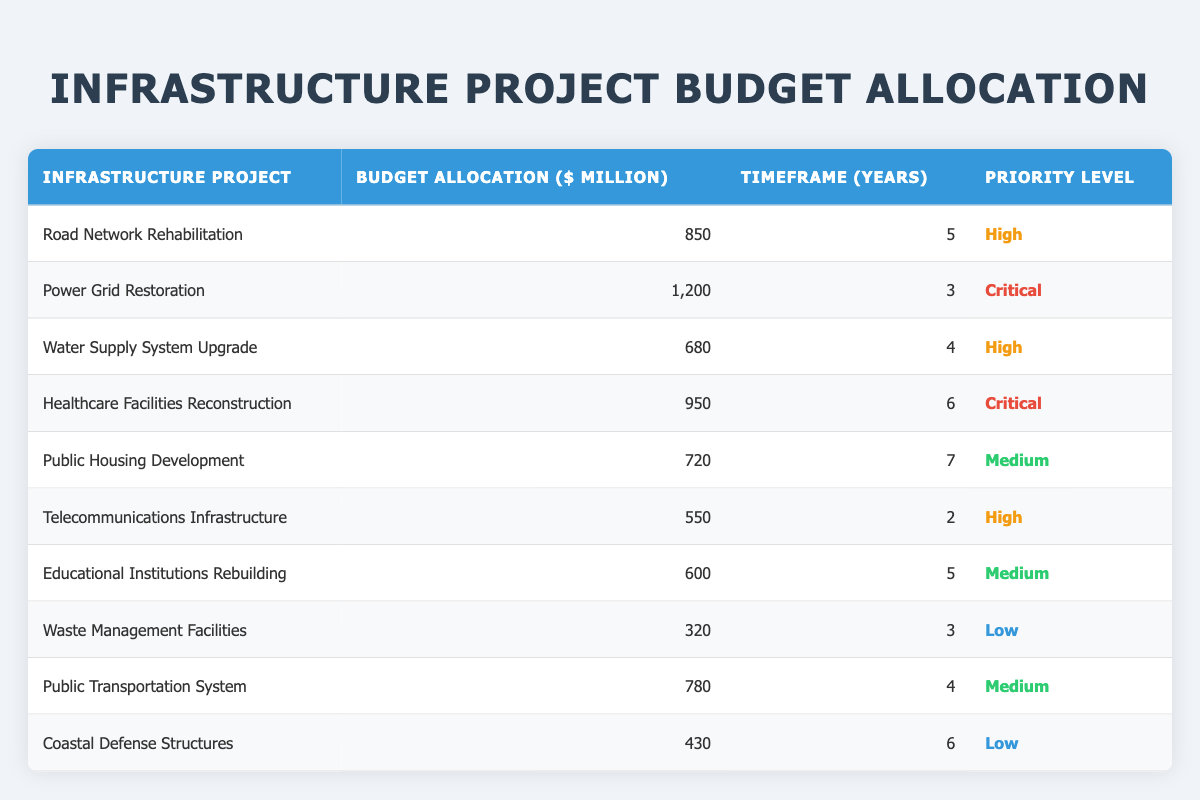What is the total budget allocation for all infrastructure projects? To find the total budget allocation, sum the budget allocations for each project: 850 + 1200 + 680 + 950 + 720 + 550 + 600 + 320 + 780 + 430 = 5,680 million dollars.
Answer: 5,680 million dollars Which infrastructure project has the longest timeframe? The timeframes for each project are listed. The longest timeframe is 7 years for the Public Housing Development project.
Answer: Public Housing Development How many projects have a "Critical" priority level? By looking at the table, we can see that there are 2 projects with a "Critical" priority level: Power Grid Restoration and Healthcare Facilities Reconstruction.
Answer: 2 What is the average budget allocation for projects with a "High" priority level? The budget allocations for projects with a "High" priority level are: 850, 680, and 550. To find the average: (850 + 680 + 550) / 3 = 690 million dollars.
Answer: 690 million dollars Is the budget allocation for Waste Management Facilities greater than that of the Coastal Defense Structures? The budget for Waste Management Facilities is 320 million, while Coastal Defense Structures is 430 million. Since 320 is not greater than 430, the answer is no.
Answer: No What is the difference in budget allocation between the project with the highest and the project with the lowest budget? The project with the highest budget is Power Grid Restoration at 1,200 million and the lowest is Waste Management Facilities at 320 million. The difference is 1,200 - 320 = 880 million dollars.
Answer: 880 million dollars Are there more projects with a "Medium" priority than those with a "Low" priority? There are 4 projects with a "Medium" priority (Public Housing Development, Educational Institutions Rebuilding, Public Transportation System) and 2 projects with a "Low" priority (Waste Management Facilities, Coastal Defense Structures), so yes, there are more "Medium" priority projects.
Answer: Yes What is the total budget allocation for projects with a "High" priority level? The budget allocations for projects marked as "High" are: 850, 680, and 550. Adding these gives: 850 + 680 + 550 = 2,080 million dollars.
Answer: 2,080 million dollars 